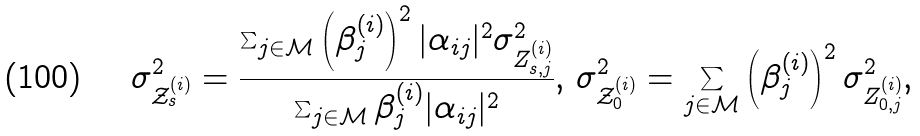<formula> <loc_0><loc_0><loc_500><loc_500>\sigma _ { \mathcal { Z } _ { s } ^ { ( i ) } } ^ { 2 } = \frac { \sum _ { j \in \mathcal { M } } \left ( \beta _ { j } ^ { ( i ) } \right ) ^ { 2 } | \alpha _ { i j } | ^ { 2 } \sigma _ { Z _ { s , j } ^ { ( i ) } } ^ { 2 } } { \sum _ { j \in \mathcal { M } } \beta _ { j } ^ { ( i ) } | \alpha _ { i j } | ^ { 2 } } , \, \sigma _ { \mathcal { Z } _ { 0 } ^ { ( i ) } } ^ { 2 } = \sum _ { j \in \mathcal { M } } \left ( \beta _ { j } ^ { ( i ) } \right ) ^ { 2 } \sigma _ { Z _ { 0 , j } ^ { ( i ) } } ^ { 2 } ,</formula> 